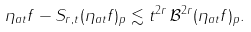Convert formula to latex. <formula><loc_0><loc_0><loc_500><loc_500>\| \eta _ { a t } f - S _ { r , t } ( \eta _ { a t } f ) \| _ { p } \lesssim t ^ { 2 r } \, \| \mathcal { B } ^ { 2 r } ( \eta _ { a t } f ) \| _ { p } .</formula> 